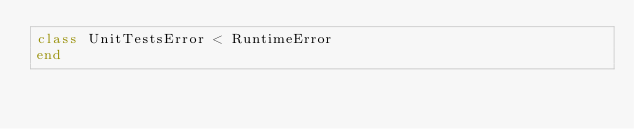Convert code to text. <code><loc_0><loc_0><loc_500><loc_500><_Ruby_>class UnitTestsError < RuntimeError
end
</code> 